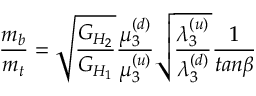<formula> <loc_0><loc_0><loc_500><loc_500>{ \frac { m _ { b } } { m _ { t } } } = { \sqrt { \frac { G _ { H _ { 2 } } } { G _ { H _ { 1 } } } } } { \frac { \mu _ { 3 } ^ { ( d ) } } { \mu _ { 3 } ^ { ( u ) } } } { \sqrt { \frac { \lambda _ { 3 } ^ { ( u ) } } { \lambda _ { 3 } ^ { ( d ) } } } } { \frac { 1 } { t a n \beta } }</formula> 